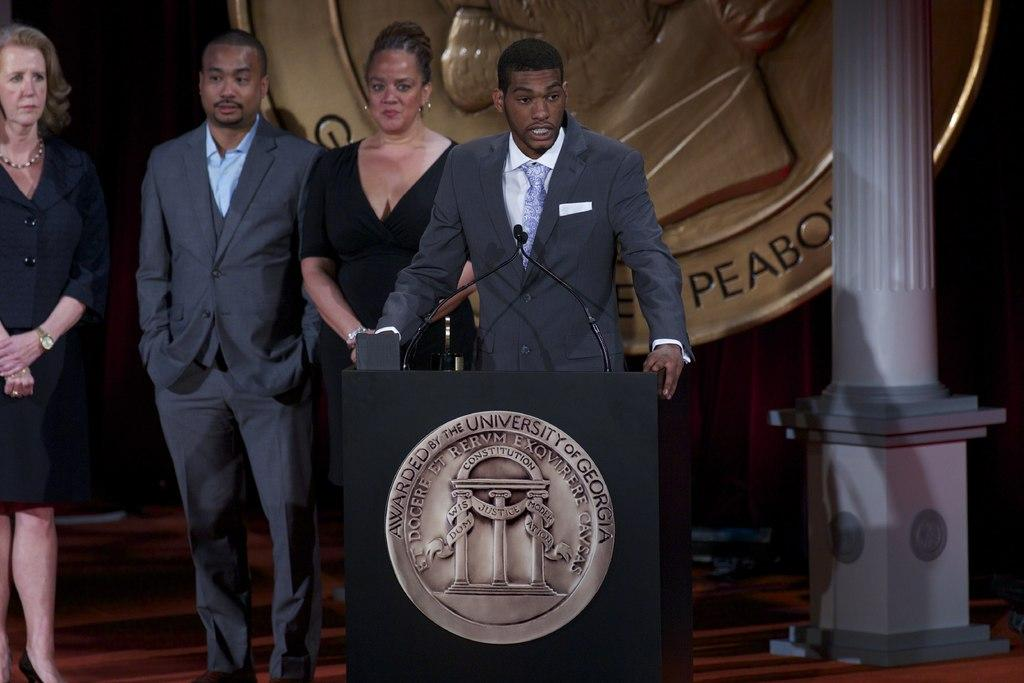Provide a one-sentence caption for the provided image. A man at a podium giving a speech with a sign behind him that has peabody on it. 